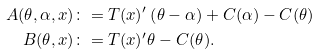<formula> <loc_0><loc_0><loc_500><loc_500>A ( \theta , \alpha , x ) & \colon = T ( x ) ^ { \prime } \left ( \theta - \alpha \right ) + C ( \alpha ) - C ( \theta ) \\ B ( \theta , x ) & \colon = T ( x ) ^ { \prime } \theta - C ( \theta ) .</formula> 